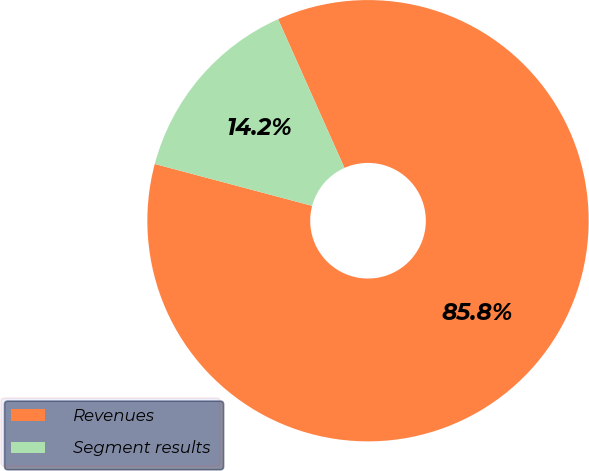<chart> <loc_0><loc_0><loc_500><loc_500><pie_chart><fcel>Revenues<fcel>Segment results<nl><fcel>85.82%<fcel>14.18%<nl></chart> 